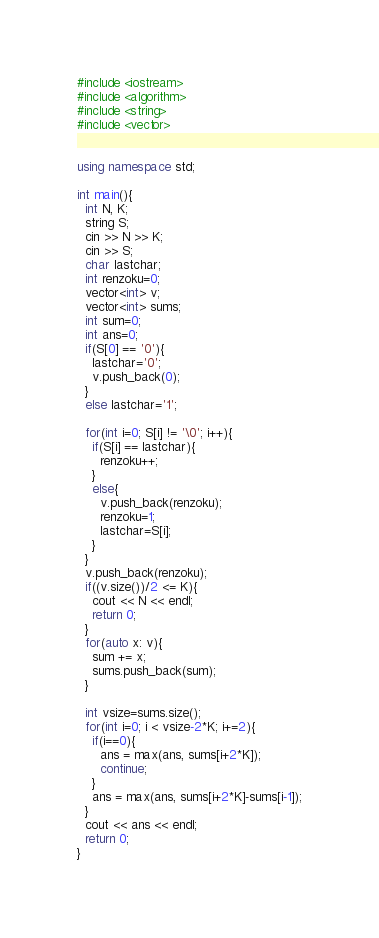Convert code to text. <code><loc_0><loc_0><loc_500><loc_500><_C++_>#include <iostream>
#include <algorithm>
#include <string>
#include <vector>


using namespace std;

int main(){
  int N, K;
  string S;
  cin >> N >> K;
  cin >> S;
  char lastchar;
  int renzoku=0;
  vector<int> v;
  vector<int> sums;
  int sum=0;
  int ans=0;
  if(S[0] == '0'){
    lastchar='0';
    v.push_back(0);
  }
  else lastchar='1';

  for(int i=0; S[i] != '\0'; i++){
    if(S[i] == lastchar){
      renzoku++;
    }
    else{
      v.push_back(renzoku);
      renzoku=1;
      lastchar=S[i];
    }
  }
  v.push_back(renzoku);
  if((v.size())/2 <= K){
    cout << N << endl;
    return 0;
  }
  for(auto x: v){
    sum += x;
    sums.push_back(sum);
  }

  int vsize=sums.size();
  for(int i=0; i < vsize-2*K; i+=2){
    if(i==0){
      ans = max(ans, sums[i+2*K]);
      continue;
    }
    ans = max(ans, sums[i+2*K]-sums[i-1]);
  }
  cout << ans << endl;
  return 0;
}
</code> 